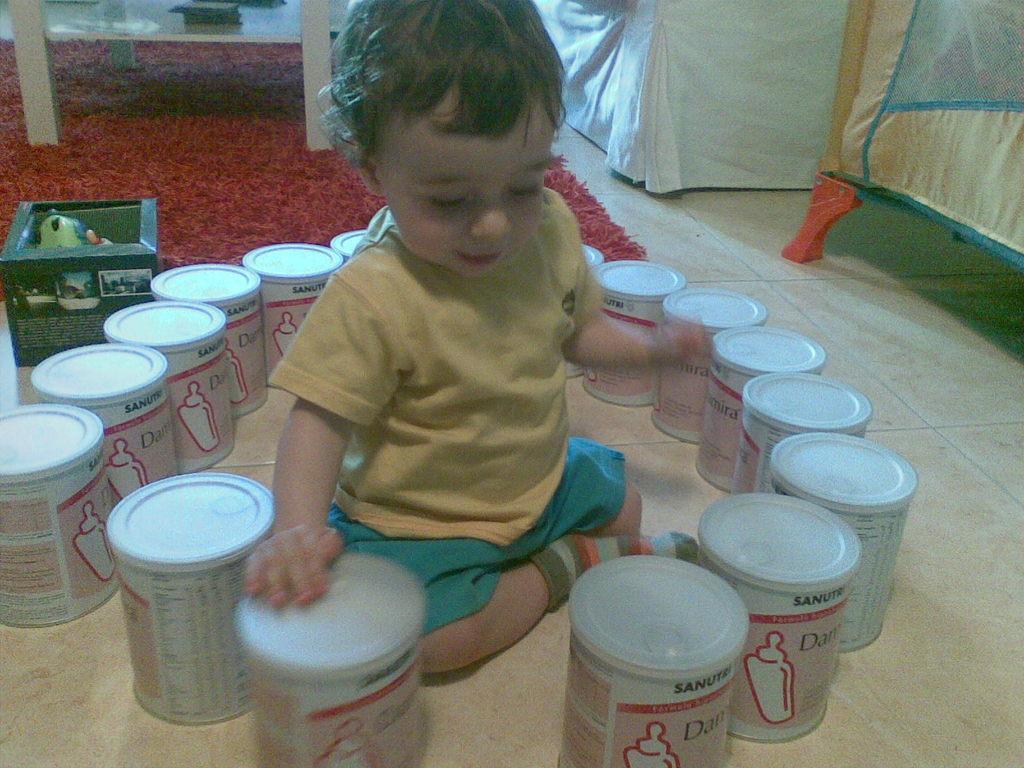Please provide a concise description of this image. In this image in the center there is one boy who is sitting and there are some boxes around him, in the background there is a carpet and box and some tents. At the bottom there is a floor. 